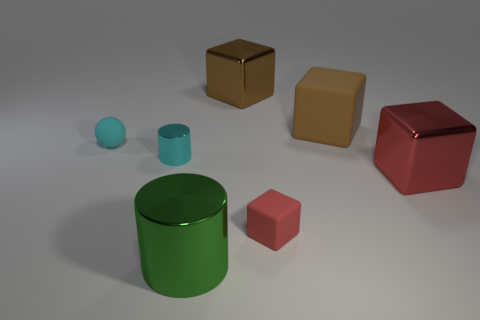Are there any other things that have the same shape as the large brown metal thing?
Offer a very short reply. Yes. Does the large red block have the same material as the brown object that is to the right of the red rubber block?
Your response must be concise. No. Are there any metal cubes that have the same color as the big matte cube?
Your answer should be compact. Yes. What number of other objects are the same material as the big green object?
Your answer should be compact. 3. Does the small shiny object have the same color as the small thing to the left of the small shiny cylinder?
Keep it short and to the point. Yes. Are there more metal things right of the big brown metal cube than red rubber cylinders?
Offer a very short reply. Yes. There is a small matte object on the left side of the shiny cube behind the cyan ball; how many red metal blocks are on the left side of it?
Offer a terse response. 0. Is the shape of the small rubber object that is on the left side of the red matte thing the same as  the tiny red rubber object?
Your response must be concise. No. What is the material of the tiny object in front of the small cylinder?
Your answer should be compact. Rubber. What shape is the rubber thing that is behind the tiny cyan shiny thing and right of the cyan ball?
Ensure brevity in your answer.  Cube. 